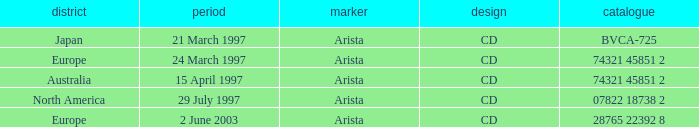What Date has the Region Europe and a Catalog of 74321 45851 2? 24 March 1997. 